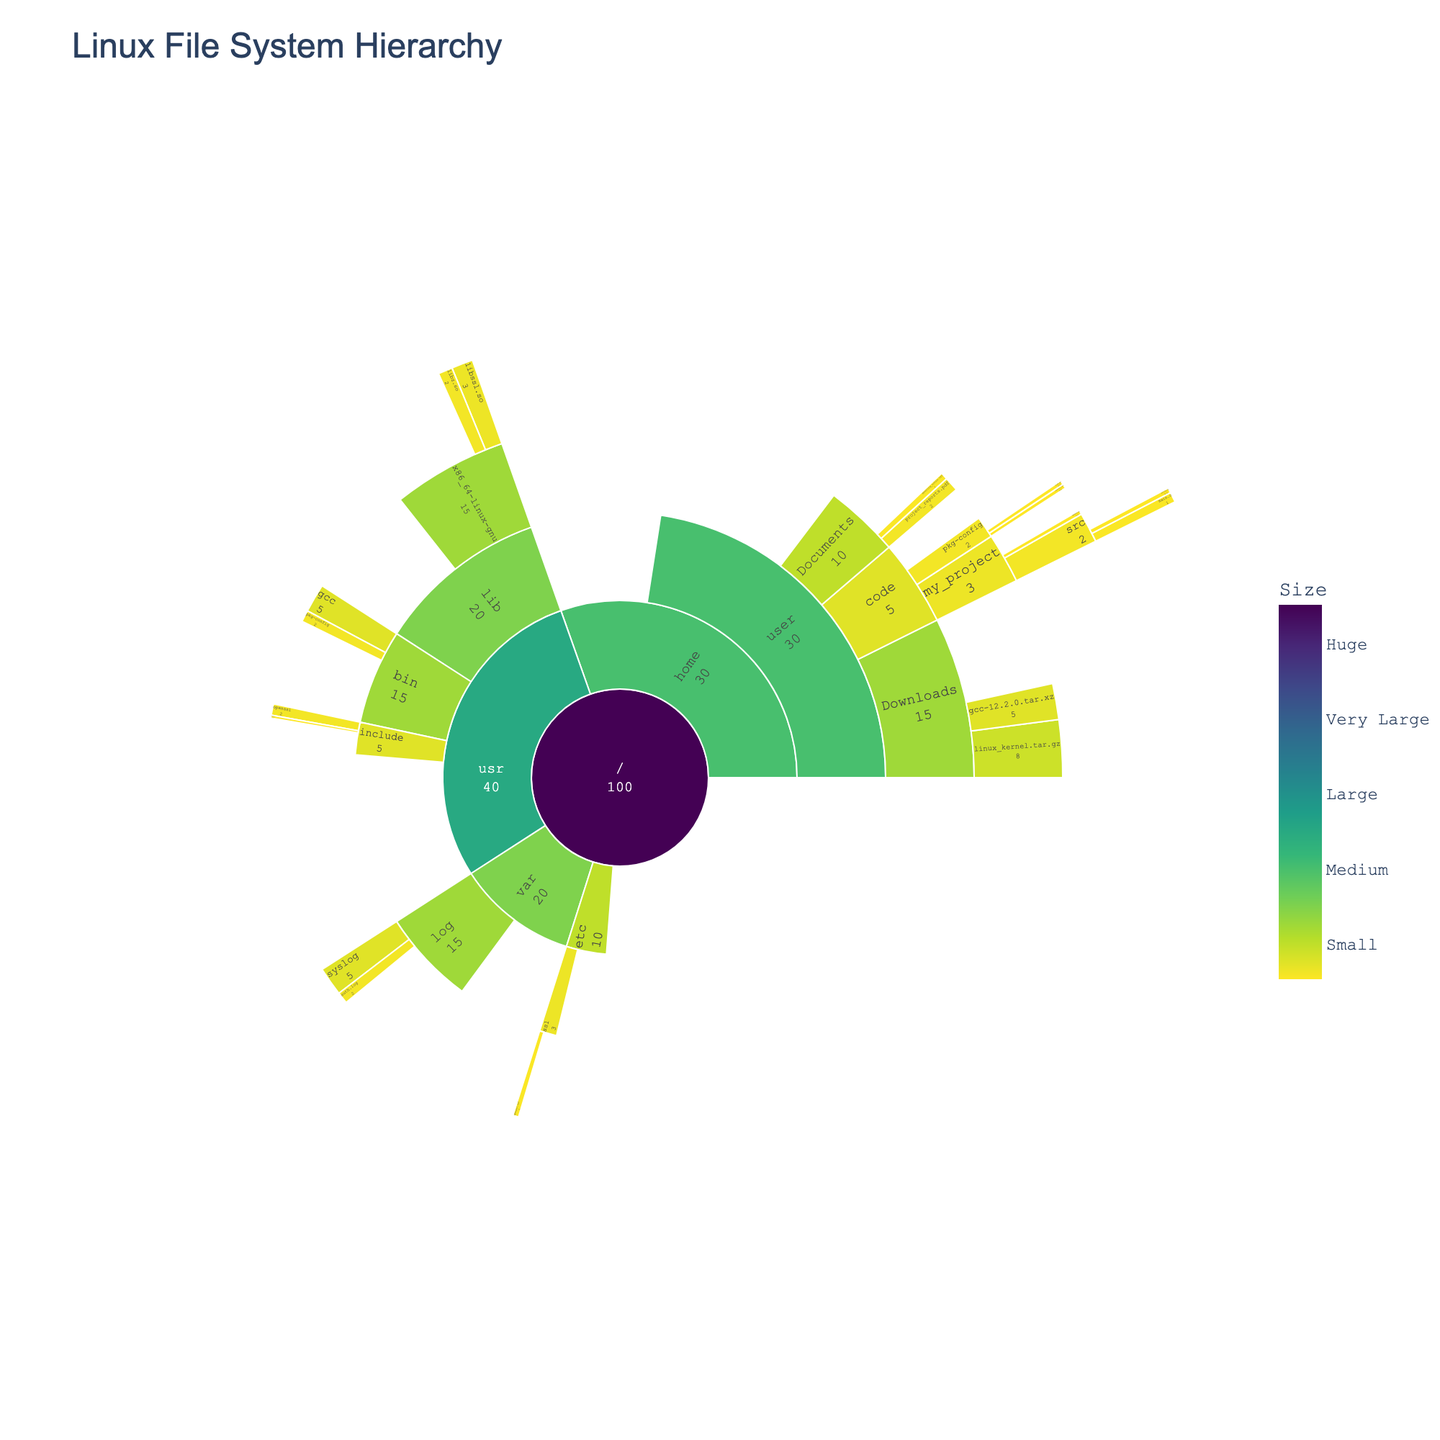What is the title of the plot? The title is usually located at the top of the plot. Here it is "Linux File System Hierarchy," which describes the hierarchical structure it represents.
Answer: Linux File System Hierarchy What is the total size of the 'home' directory? The 'home' directory is a part of the hierarchy whose size is displayed within the plot. By looking at the value associated with 'home', we see it is 30.
Answer: 30 Which file is larger, 'linux_kernel.tar.gz' or 'gcc-12.2.0.tar.xz'? By locating these files within the 'Downloads' directory in the plot, we can compare their sizes. The size of 'linux_kernel.tar.gz' is 8, whereas 'gcc-12.2.0.tar.xz' is 5.
Answer: linux_kernel.tar.gz What is the combined size of the 'Documents' and 'Downloads' directories? Find the sizes of 'Documents' and 'Downloads' directories, which are 10 and 15, respectively, within the 'home' directory. Adding these values gives 10 + 15 = 25.
Answer: 25 Are there more files in the 'etc' or 'var' directory? By counting the number of leaves in each directory, we find that 'etc' has 1 file (openssl.cnf), whereas 'var' has 2 files (syslog and auth.log).
Answer: var Which directory under 'usr' has the largest size? Within the 'usr' directory, we compare the sizes of 'bin', 'lib', and 'include'. 'lib' has the largest size, which is 20.
Answer: lib How many directories are there under the root ('/') directory? The sunburst plot shows the immediate children of the root directory ('/'). They are 'home', 'usr', 'etc', and 'var', so there are 4 directories.
Answer: 4 Which directory contains the 'main.c' file? Navigate through the plot to find which directory contains 'main.c'. It is located under 'home' -> 'user' -> 'code' -> 'my_project' -> 'src'.
Answer: src What is the size difference between the 'libssl.so' file and the 'libz.so' file? By locating these files in the 'lib' directory, we see that 'libssl.so' is 3 and 'libz.so' is 2. The size difference is 3 - 2 = 1.
Answer: 1 What is the largest file within the 'log' directory? Under the 'log' directory, we compare the sizes of 'syslog' and 'auth.log'. 'syslog' is 5, and 'auth.log' is 2, making 'syslog' the largest.
Answer: syslog 